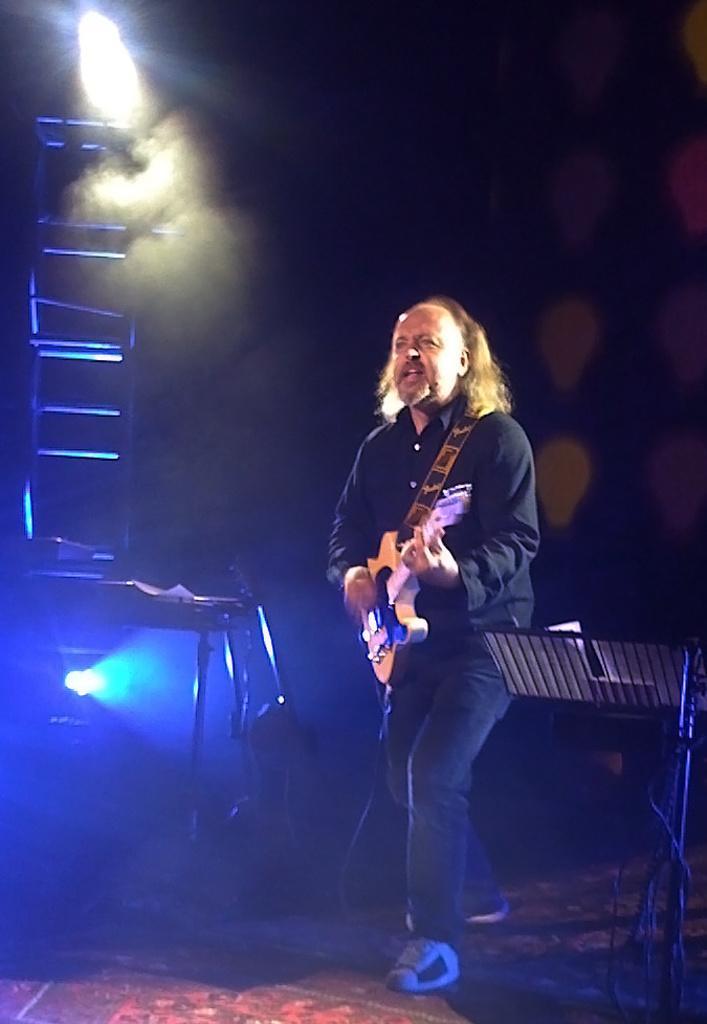In one or two sentences, can you explain what this image depicts? In the picture we can see a man standing on the floor and playing a guitar and he is with long hair and black shirt and behind him we can see a some lights and smoke near it in the dark. 